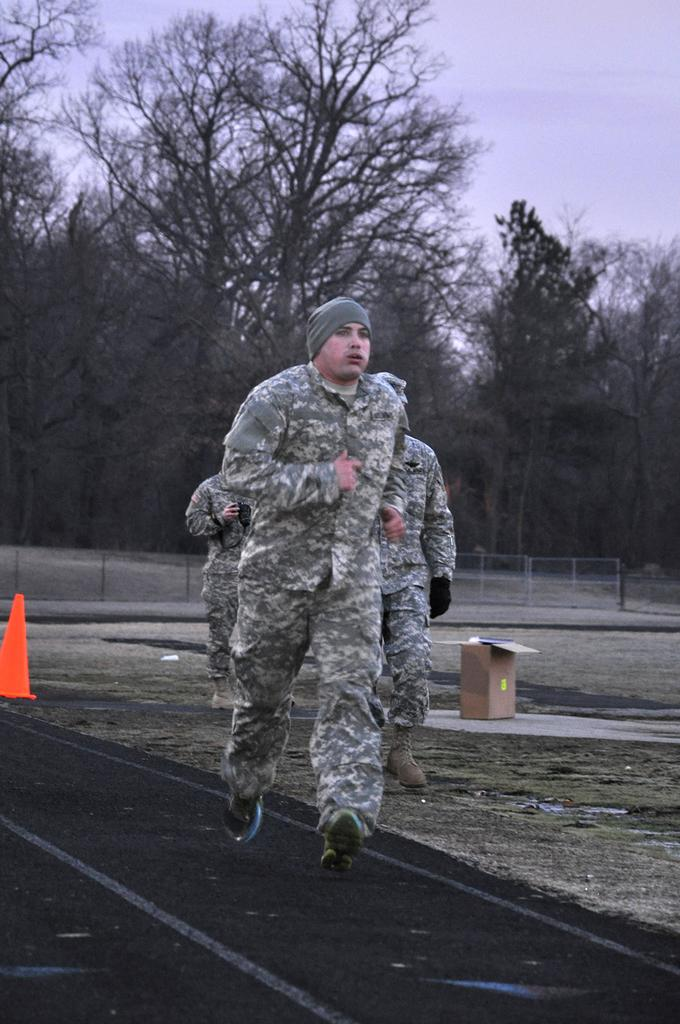What is the man in the image doing? The man is running on a track in the image. Can you describe the people behind the man? There are two persons behind the man. What object can be seen in the image that is typically used for holding liquids? There is a carton in the image. What safety object is present in the image? There is a traffic cone in the image. What type of natural scenery is visible in the background of the image? There are trees in the background of the image. What type of boundary can be seen in the background of the image? There is a boundary in the background of the image. What type of bread is being sliced with a knife in the image? There is no bread or knife present in the image. 